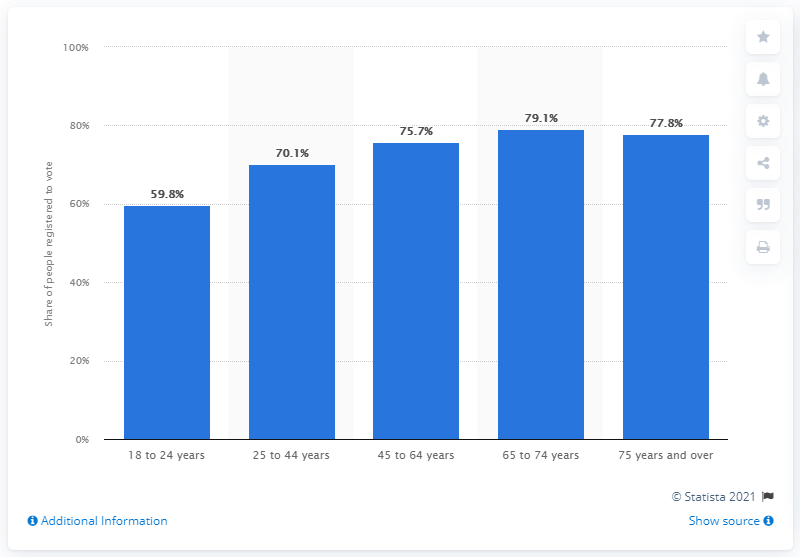Draw attention to some important aspects in this diagram. In 2020, it was reported that 79.1% of individuals between the ages of 65 and 74 were registered to vote. 